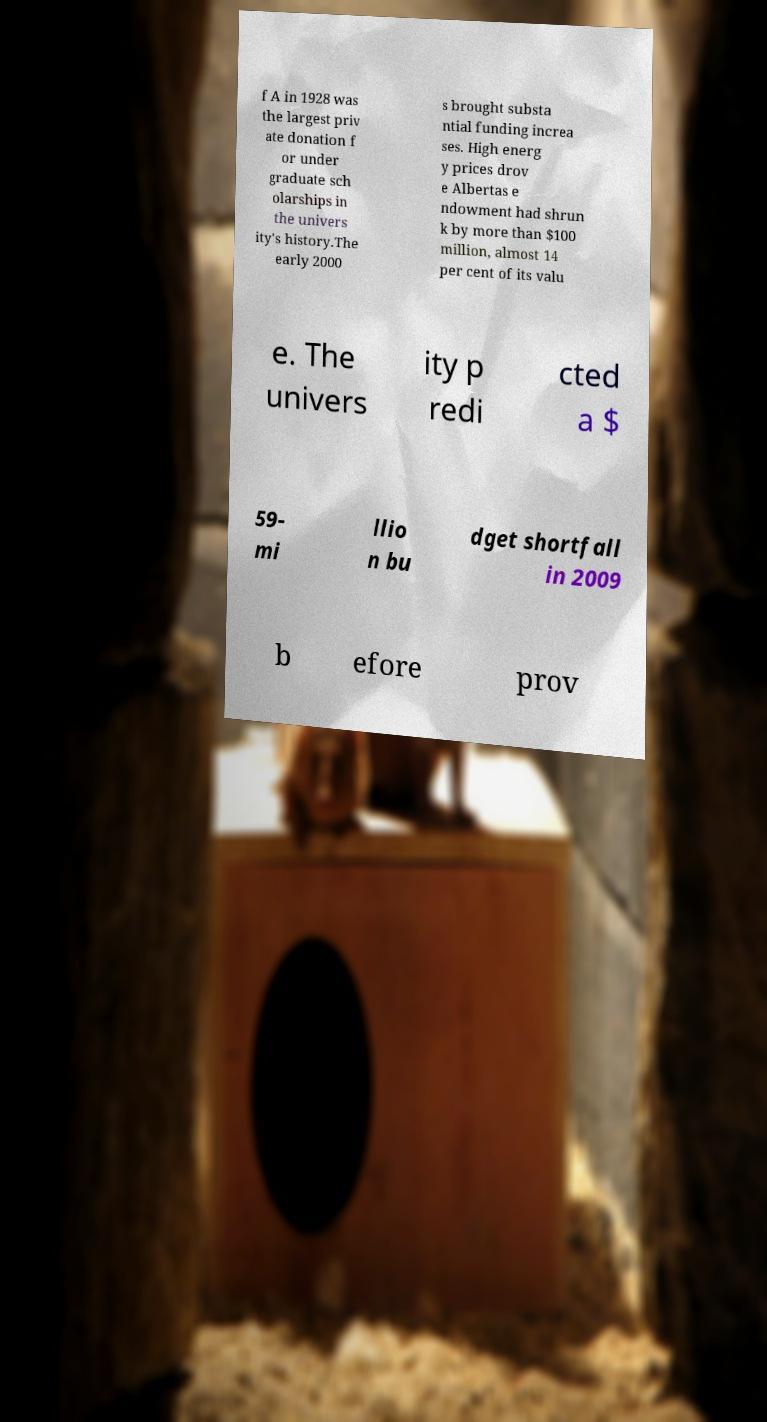Can you accurately transcribe the text from the provided image for me? f A in 1928 was the largest priv ate donation f or under graduate sch olarships in the univers ity's history.The early 2000 s brought substa ntial funding increa ses. High energ y prices drov e Albertas e ndowment had shrun k by more than $100 million, almost 14 per cent of its valu e. The univers ity p redi cted a $ 59- mi llio n bu dget shortfall in 2009 b efore prov 